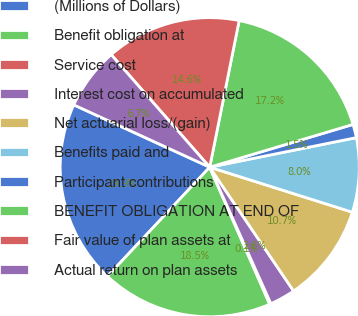Convert chart. <chart><loc_0><loc_0><loc_500><loc_500><pie_chart><fcel>(Millions of Dollars)<fcel>Benefit obligation at<fcel>Service cost<fcel>Interest cost on accumulated<fcel>Net actuarial loss/(gain)<fcel>Benefits paid and<fcel>Participant contributions<fcel>BENEFIT OBLIGATION AT END OF<fcel>Fair value of plan assets at<fcel>Actual return on plan assets<nl><fcel>19.86%<fcel>18.55%<fcel>0.14%<fcel>2.77%<fcel>10.66%<fcel>8.03%<fcel>1.45%<fcel>17.23%<fcel>14.6%<fcel>6.71%<nl></chart> 